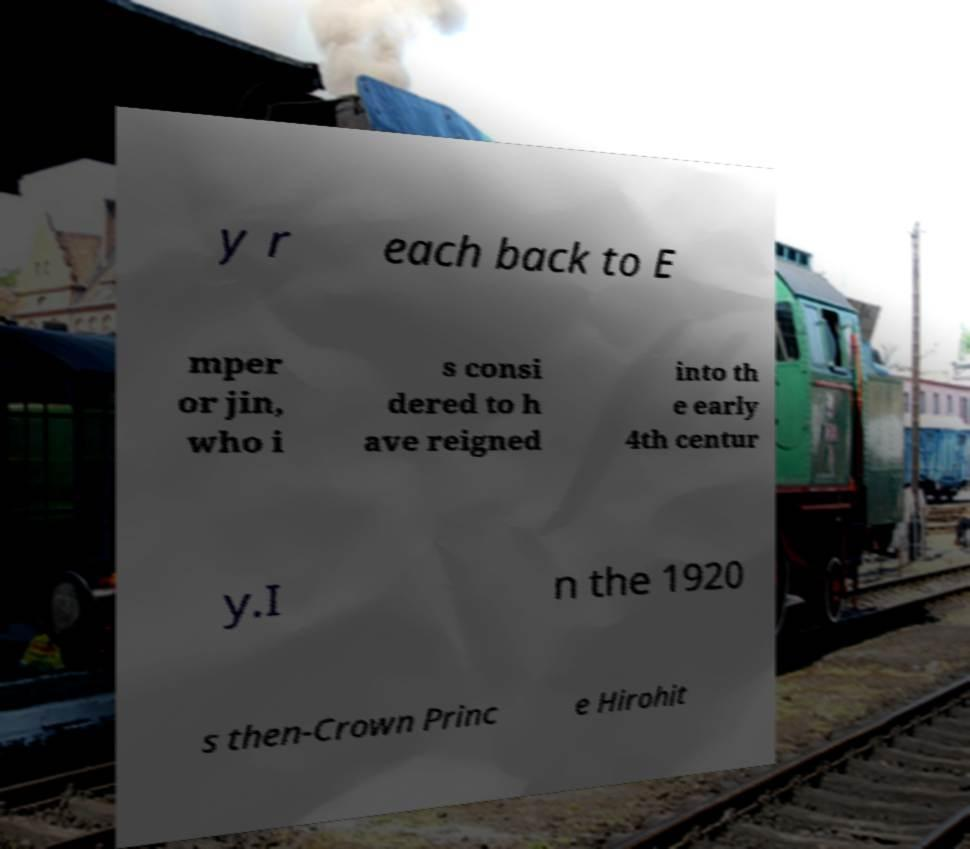Please identify and transcribe the text found in this image. y r each back to E mper or jin, who i s consi dered to h ave reigned into th e early 4th centur y.I n the 1920 s then-Crown Princ e Hirohit 